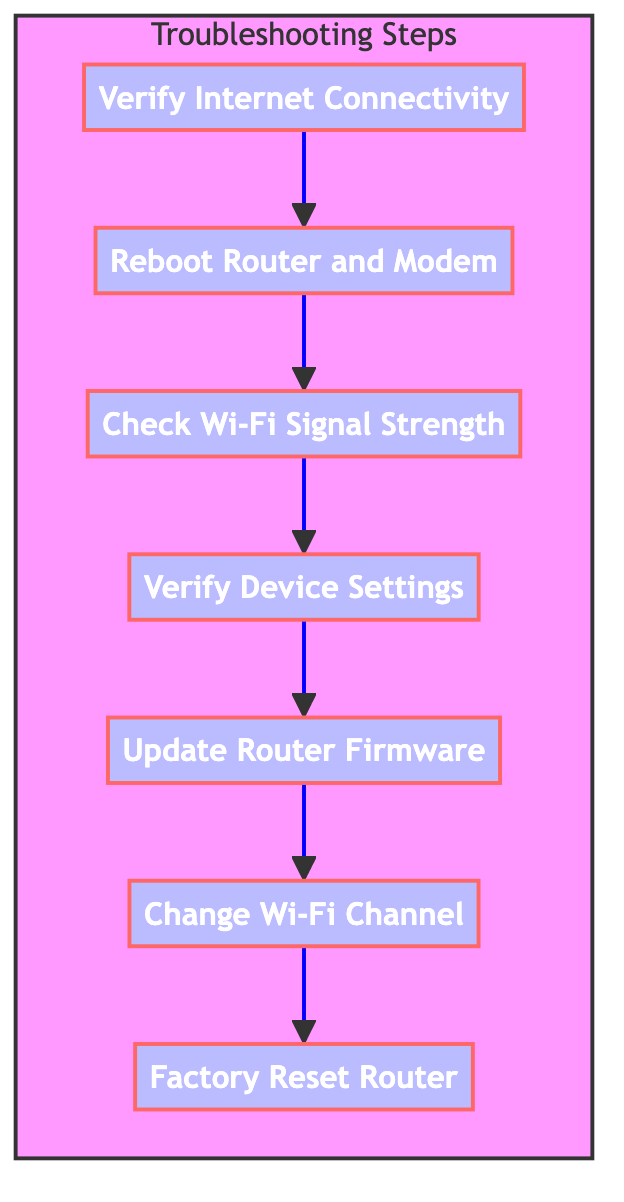What is the first step in the flow chart? The flow chart begins with the step "Factory Reset Router" which is the first node at the bottom of the diagram.
Answer: Factory Reset Router How many steps are there in total? Counting all the steps from "Factory Reset Router" to "Verify Internet Connectivity," there are seven distinct steps within the flow chart, indicating a thorough troubleshooting process.
Answer: 7 What follows after checking Wi-Fi signal strength? After "Check Wi-Fi Signal Strength," the next step in the flow chart is "Verify Device Settings," indicating that if the signal strength is adequate, users should check their device settings next.
Answer: Verify Device Settings Which step does lead to changing the Wi-Fi channel? The step that leads to "Change Wi-Fi Channel" is "Update Router Firmware." This means that, once firmware is updated, changing the Wi-Fi channel becomes the next recommended action.
Answer: Update Router Firmware What is the last step recommended in the troubleshooting process? The last recommended step in the flow chart is "Factory Reset Router," which is a last resort action to restore default settings if previous steps did not resolve the issue.
Answer: Factory Reset Router What is the relationship between rebooting the router and verifying internet connectivity? The relationship is sequential: after verifying internet connectivity with the step "Verify Internet Connectivity," the next step is to "Reboot Router and Modem," suggesting that rebooting is a solution if there are connectivity issues.
Answer: Reboot Router and Modem Is "Update Router Firmware" an intermediate step or the initial step? "Update Router Firmware" is an intermediate step; it comes after several other troubleshooting actions, indicating that it follows prior checks and adjustments.
Answer: Intermediate step Which two steps are directly connected in the flow before updating router firmware? The two steps that are directly connected before "Update Router Firmware" are "Verify Device Settings" and "Check Wi-Fi Signal Strength," indicating a logical flow of actions to verify user configuration prior to firmware updates.
Answer: Verify Device Settings and Check Wi-Fi Signal Strength 